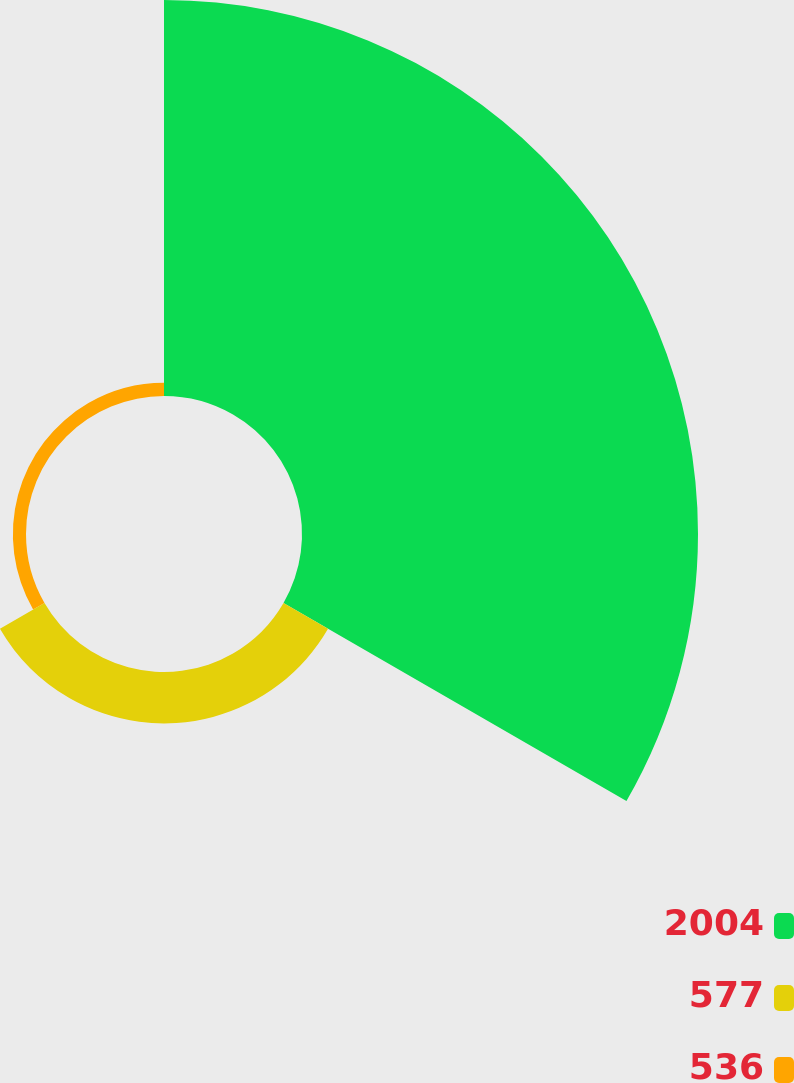<chart> <loc_0><loc_0><loc_500><loc_500><pie_chart><fcel>2004<fcel>577<fcel>536<nl><fcel>85.98%<fcel>11.16%<fcel>2.85%<nl></chart> 